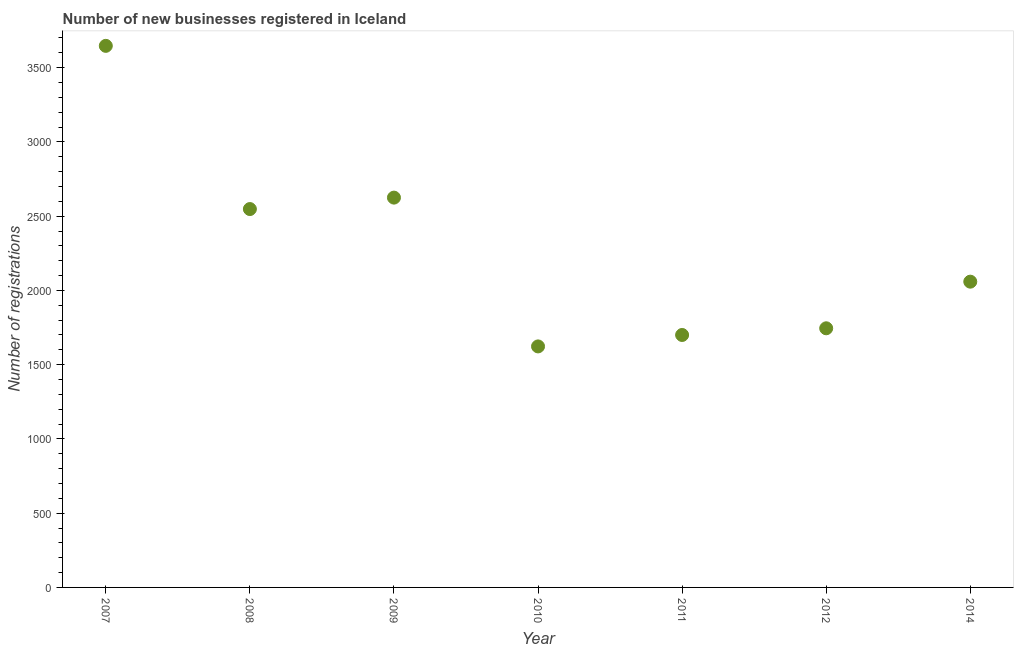What is the number of new business registrations in 2014?
Your answer should be compact. 2059. Across all years, what is the maximum number of new business registrations?
Keep it short and to the point. 3647. Across all years, what is the minimum number of new business registrations?
Your answer should be compact. 1623. In which year was the number of new business registrations maximum?
Provide a short and direct response. 2007. In which year was the number of new business registrations minimum?
Provide a succinct answer. 2010. What is the sum of the number of new business registrations?
Your response must be concise. 1.59e+04. What is the difference between the number of new business registrations in 2009 and 2014?
Make the answer very short. 566. What is the average number of new business registrations per year?
Keep it short and to the point. 2278.14. What is the median number of new business registrations?
Keep it short and to the point. 2059. What is the ratio of the number of new business registrations in 2010 to that in 2014?
Offer a very short reply. 0.79. Is the number of new business registrations in 2009 less than that in 2010?
Give a very brief answer. No. Is the difference between the number of new business registrations in 2008 and 2014 greater than the difference between any two years?
Your answer should be very brief. No. What is the difference between the highest and the second highest number of new business registrations?
Provide a short and direct response. 1022. What is the difference between the highest and the lowest number of new business registrations?
Offer a very short reply. 2024. In how many years, is the number of new business registrations greater than the average number of new business registrations taken over all years?
Ensure brevity in your answer.  3. Does the number of new business registrations monotonically increase over the years?
Your response must be concise. No. How many years are there in the graph?
Offer a terse response. 7. Are the values on the major ticks of Y-axis written in scientific E-notation?
Make the answer very short. No. Does the graph contain grids?
Give a very brief answer. No. What is the title of the graph?
Offer a terse response. Number of new businesses registered in Iceland. What is the label or title of the X-axis?
Make the answer very short. Year. What is the label or title of the Y-axis?
Ensure brevity in your answer.  Number of registrations. What is the Number of registrations in 2007?
Offer a terse response. 3647. What is the Number of registrations in 2008?
Offer a very short reply. 2548. What is the Number of registrations in 2009?
Your answer should be very brief. 2625. What is the Number of registrations in 2010?
Your answer should be compact. 1623. What is the Number of registrations in 2011?
Your answer should be very brief. 1700. What is the Number of registrations in 2012?
Make the answer very short. 1745. What is the Number of registrations in 2014?
Your answer should be very brief. 2059. What is the difference between the Number of registrations in 2007 and 2008?
Offer a terse response. 1099. What is the difference between the Number of registrations in 2007 and 2009?
Your answer should be compact. 1022. What is the difference between the Number of registrations in 2007 and 2010?
Provide a succinct answer. 2024. What is the difference between the Number of registrations in 2007 and 2011?
Provide a short and direct response. 1947. What is the difference between the Number of registrations in 2007 and 2012?
Make the answer very short. 1902. What is the difference between the Number of registrations in 2007 and 2014?
Provide a short and direct response. 1588. What is the difference between the Number of registrations in 2008 and 2009?
Your answer should be very brief. -77. What is the difference between the Number of registrations in 2008 and 2010?
Offer a very short reply. 925. What is the difference between the Number of registrations in 2008 and 2011?
Offer a very short reply. 848. What is the difference between the Number of registrations in 2008 and 2012?
Make the answer very short. 803. What is the difference between the Number of registrations in 2008 and 2014?
Your response must be concise. 489. What is the difference between the Number of registrations in 2009 and 2010?
Keep it short and to the point. 1002. What is the difference between the Number of registrations in 2009 and 2011?
Offer a terse response. 925. What is the difference between the Number of registrations in 2009 and 2012?
Your answer should be compact. 880. What is the difference between the Number of registrations in 2009 and 2014?
Your answer should be compact. 566. What is the difference between the Number of registrations in 2010 and 2011?
Your answer should be very brief. -77. What is the difference between the Number of registrations in 2010 and 2012?
Ensure brevity in your answer.  -122. What is the difference between the Number of registrations in 2010 and 2014?
Provide a succinct answer. -436. What is the difference between the Number of registrations in 2011 and 2012?
Your answer should be very brief. -45. What is the difference between the Number of registrations in 2011 and 2014?
Your answer should be very brief. -359. What is the difference between the Number of registrations in 2012 and 2014?
Give a very brief answer. -314. What is the ratio of the Number of registrations in 2007 to that in 2008?
Keep it short and to the point. 1.43. What is the ratio of the Number of registrations in 2007 to that in 2009?
Offer a terse response. 1.39. What is the ratio of the Number of registrations in 2007 to that in 2010?
Offer a terse response. 2.25. What is the ratio of the Number of registrations in 2007 to that in 2011?
Provide a succinct answer. 2.15. What is the ratio of the Number of registrations in 2007 to that in 2012?
Ensure brevity in your answer.  2.09. What is the ratio of the Number of registrations in 2007 to that in 2014?
Your answer should be very brief. 1.77. What is the ratio of the Number of registrations in 2008 to that in 2009?
Offer a terse response. 0.97. What is the ratio of the Number of registrations in 2008 to that in 2010?
Your response must be concise. 1.57. What is the ratio of the Number of registrations in 2008 to that in 2011?
Offer a very short reply. 1.5. What is the ratio of the Number of registrations in 2008 to that in 2012?
Your answer should be very brief. 1.46. What is the ratio of the Number of registrations in 2008 to that in 2014?
Your response must be concise. 1.24. What is the ratio of the Number of registrations in 2009 to that in 2010?
Give a very brief answer. 1.62. What is the ratio of the Number of registrations in 2009 to that in 2011?
Your answer should be compact. 1.54. What is the ratio of the Number of registrations in 2009 to that in 2012?
Ensure brevity in your answer.  1.5. What is the ratio of the Number of registrations in 2009 to that in 2014?
Your response must be concise. 1.27. What is the ratio of the Number of registrations in 2010 to that in 2011?
Keep it short and to the point. 0.95. What is the ratio of the Number of registrations in 2010 to that in 2012?
Make the answer very short. 0.93. What is the ratio of the Number of registrations in 2010 to that in 2014?
Your response must be concise. 0.79. What is the ratio of the Number of registrations in 2011 to that in 2014?
Provide a short and direct response. 0.83. What is the ratio of the Number of registrations in 2012 to that in 2014?
Provide a succinct answer. 0.85. 